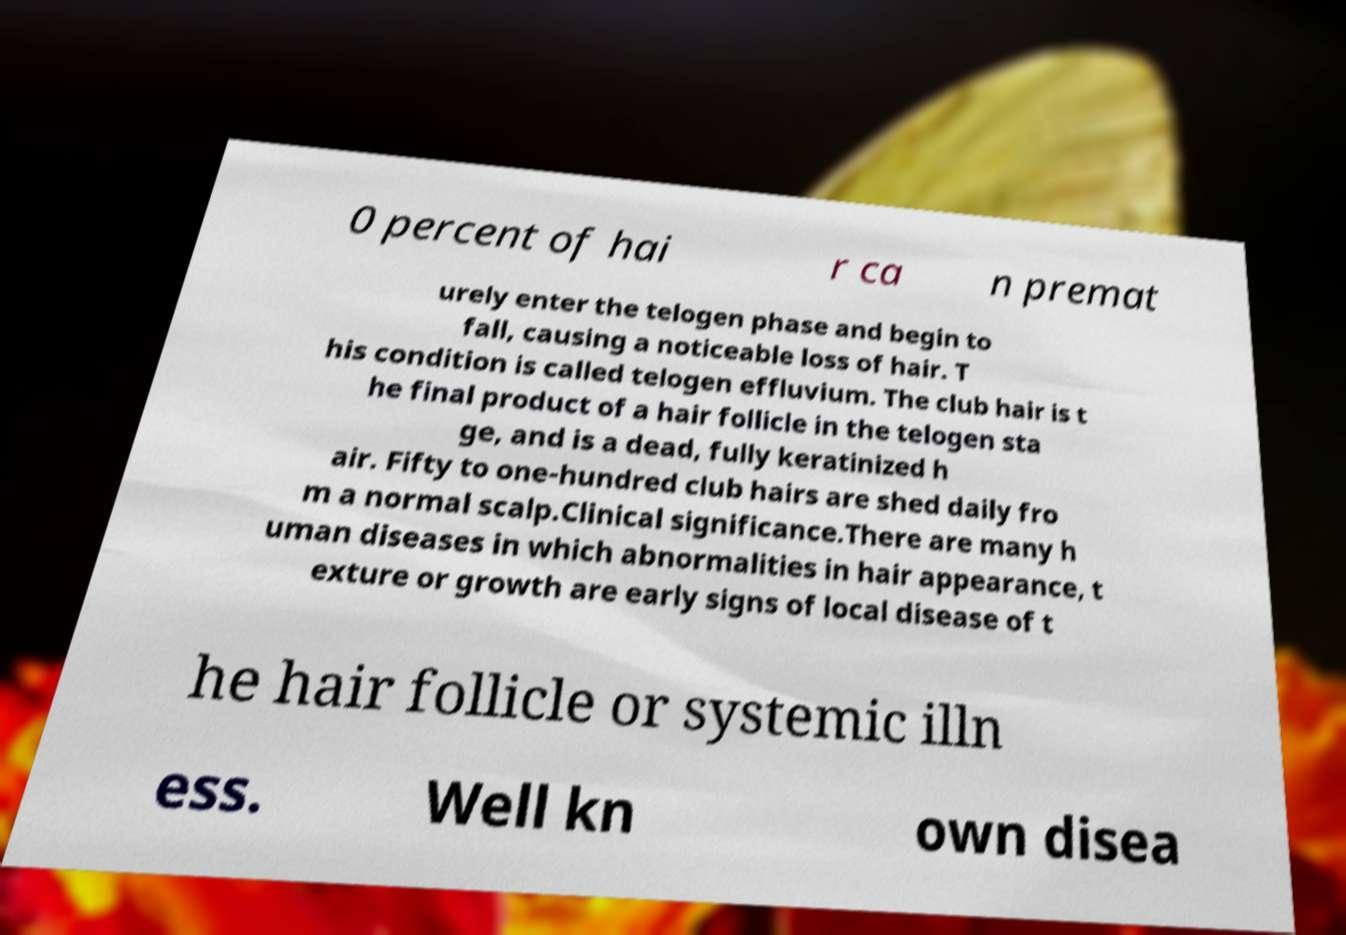Can you accurately transcribe the text from the provided image for me? 0 percent of hai r ca n premat urely enter the telogen phase and begin to fall, causing a noticeable loss of hair. T his condition is called telogen effluvium. The club hair is t he final product of a hair follicle in the telogen sta ge, and is a dead, fully keratinized h air. Fifty to one-hundred club hairs are shed daily fro m a normal scalp.Clinical significance.There are many h uman diseases in which abnormalities in hair appearance, t exture or growth are early signs of local disease of t he hair follicle or systemic illn ess. Well kn own disea 